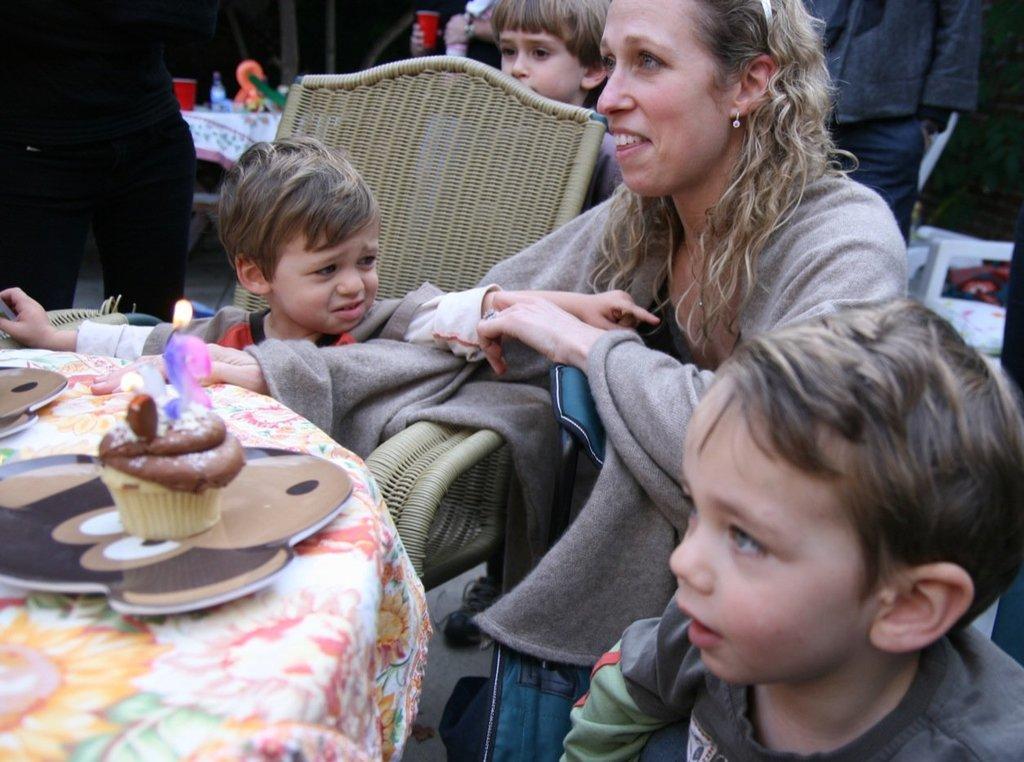Can you describe this image briefly? In this image I can see few children, a woman, a chair and here I can see a table. On this table I can see a few stuffs, a cupcake and a candle. In the background I can see few people are standing and I can also see few stuffs over there. 